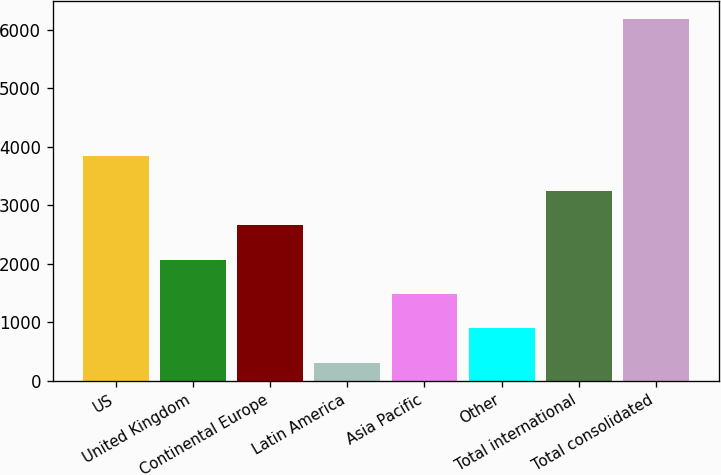Convert chart to OTSL. <chart><loc_0><loc_0><loc_500><loc_500><bar_chart><fcel>US<fcel>United Kingdom<fcel>Continental Europe<fcel>Latin America<fcel>Asia Pacific<fcel>Other<fcel>Total international<fcel>Total consolidated<nl><fcel>3835.84<fcel>2069.62<fcel>2658.36<fcel>303.4<fcel>1480.88<fcel>892.14<fcel>3247.1<fcel>6190.8<nl></chart> 